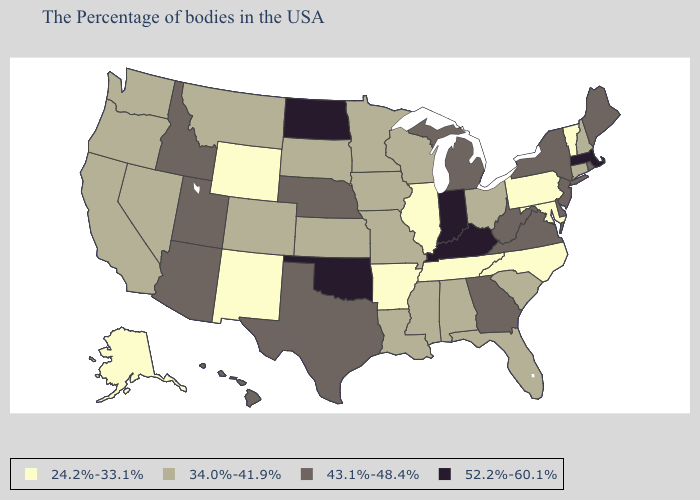Does Texas have the lowest value in the South?
Be succinct. No. Name the states that have a value in the range 52.2%-60.1%?
Quick response, please. Massachusetts, Kentucky, Indiana, Oklahoma, North Dakota. What is the value of Alaska?
Write a very short answer. 24.2%-33.1%. Name the states that have a value in the range 52.2%-60.1%?
Be succinct. Massachusetts, Kentucky, Indiana, Oklahoma, North Dakota. What is the value of Utah?
Keep it brief. 43.1%-48.4%. What is the highest value in the West ?
Short answer required. 43.1%-48.4%. What is the highest value in the MidWest ?
Quick response, please. 52.2%-60.1%. Name the states that have a value in the range 43.1%-48.4%?
Keep it brief. Maine, Rhode Island, New York, New Jersey, Delaware, Virginia, West Virginia, Georgia, Michigan, Nebraska, Texas, Utah, Arizona, Idaho, Hawaii. Among the states that border Georgia , which have the highest value?
Quick response, please. South Carolina, Florida, Alabama. What is the value of South Dakota?
Write a very short answer. 34.0%-41.9%. Does Vermont have the lowest value in the Northeast?
Give a very brief answer. Yes. Which states have the lowest value in the USA?
Keep it brief. Vermont, Maryland, Pennsylvania, North Carolina, Tennessee, Illinois, Arkansas, Wyoming, New Mexico, Alaska. Does North Dakota have the highest value in the USA?
Answer briefly. Yes. Name the states that have a value in the range 52.2%-60.1%?
Short answer required. Massachusetts, Kentucky, Indiana, Oklahoma, North Dakota. Among the states that border Alabama , which have the highest value?
Concise answer only. Georgia. 